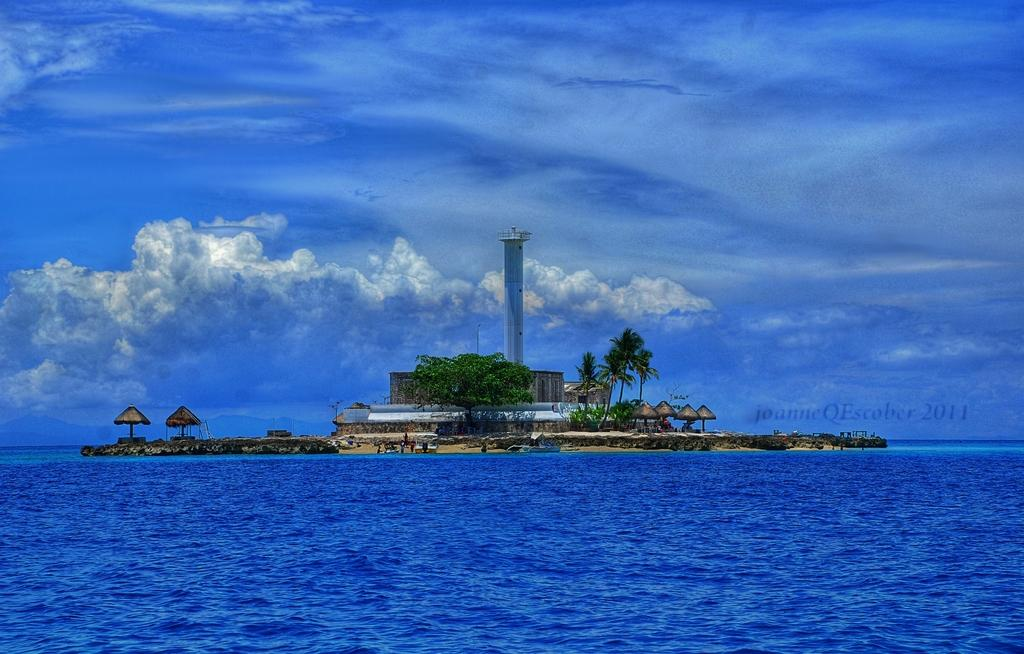What type of buildings can be seen in the image? There is a house and huts in the image. What natural elements are present in the image? There are trees and the ocean visible in the image. What is the condition of the sky in the image? The sky is cloudy in the image. What man-made structure is present in the image? There is a tower in the image. Are there any words or letters in the image? Yes, there is text on the image. Can you see a veil blowing in the wind in the image? There is no veil present in the image. How many people are walking along the beach in the image? There are no people visible in the image. 